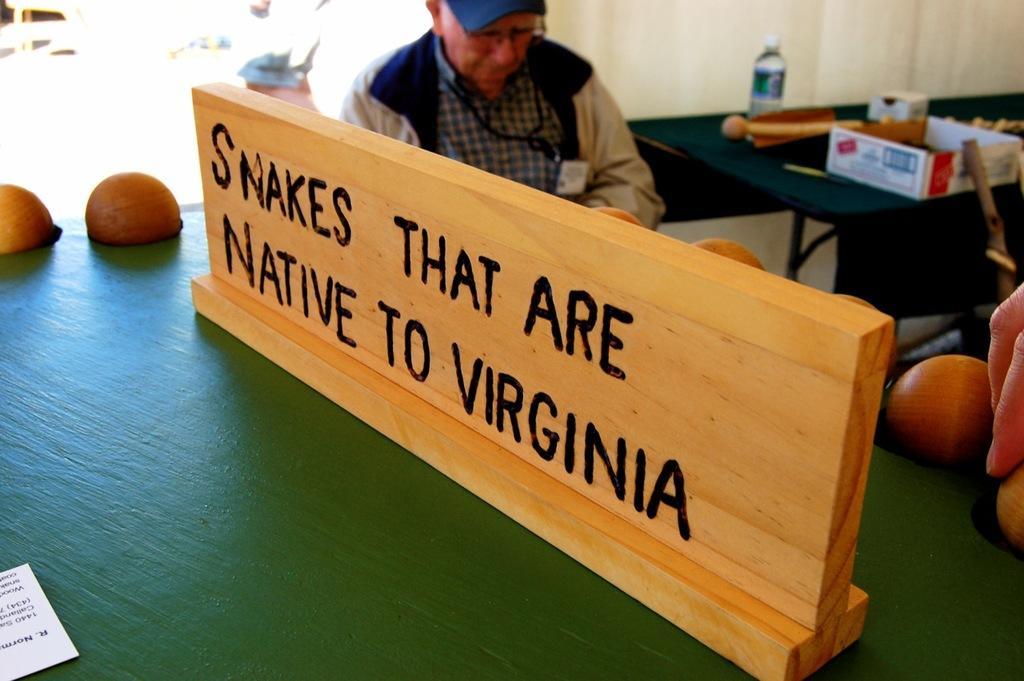Please provide a concise description of this image. In this image we can see a wooden board with text on it, man sitting on the chair and a table on which there are disposable bottle and a cardboard carton. 